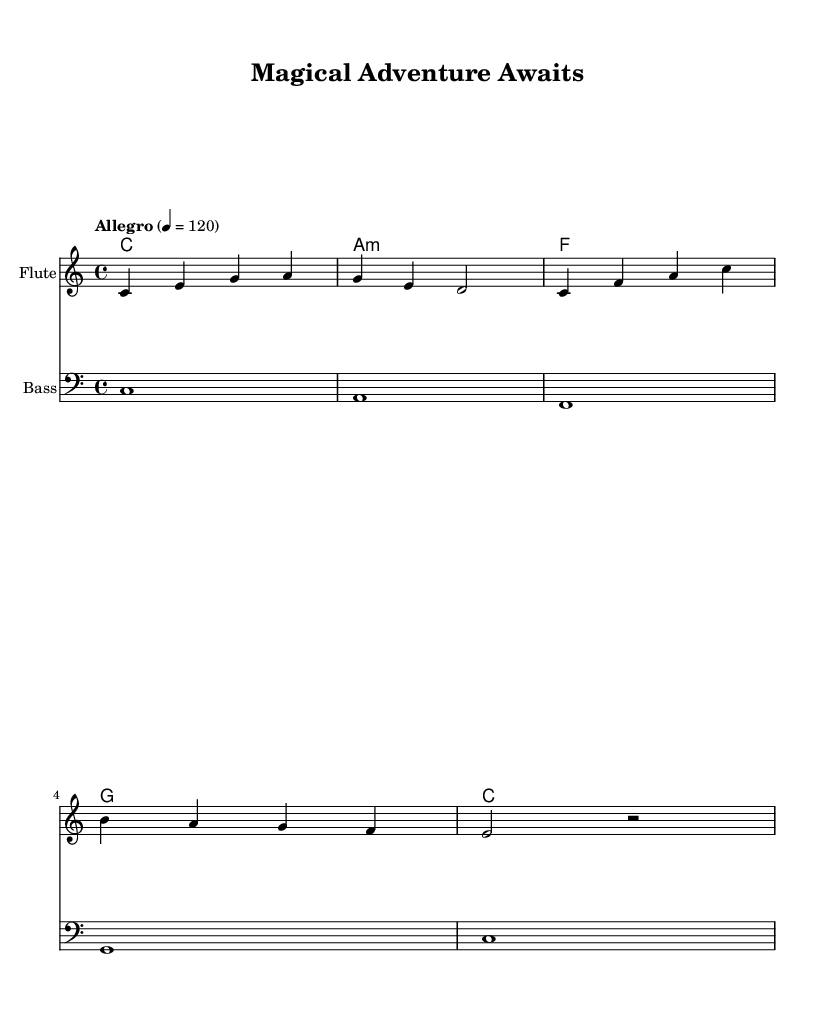What is the key signature of this music? The key signature is indicated in the global section of the sheet music and shows that the piece is in C major, which has no sharps or flats.
Answer: C major What is the time signature of this music? The time signature is found in the global section as well, presented as 4/4, meaning there are four beats in each measure and a quarter note receives one beat.
Answer: 4/4 What is the tempo marking for this piece? The tempo marking is specified in the global section where it indicates the tempo as "Allegro" with a metronome mark of quarter note = 120, suggesting a fast pace.
Answer: Allegro How many measures are in the melody? By counting the individual phrases and looking at the vertical lines (bar lines), one can see there are 5 measures in the melody section.
Answer: 5 What type of instrument is indicated for the melody? In the score section, the first staff is labeled “Flute,” indicating that the melody is intended to be played by this instrument.
Answer: Flute Which chord is played in the final measure of the harmonies? In the harmonies section, the last chord is shown to be C, as indicated by the final notation in the chord mode which shows the progression leading to this chord.
Answer: C What is the role of the bass in this piece? The bass line, indicated in the score, provides the foundational notes played in a lower register (clef bass), complementing the melody via harmonic support. It anchors the harmony throughout the piece.
Answer: Pizzicato strings 